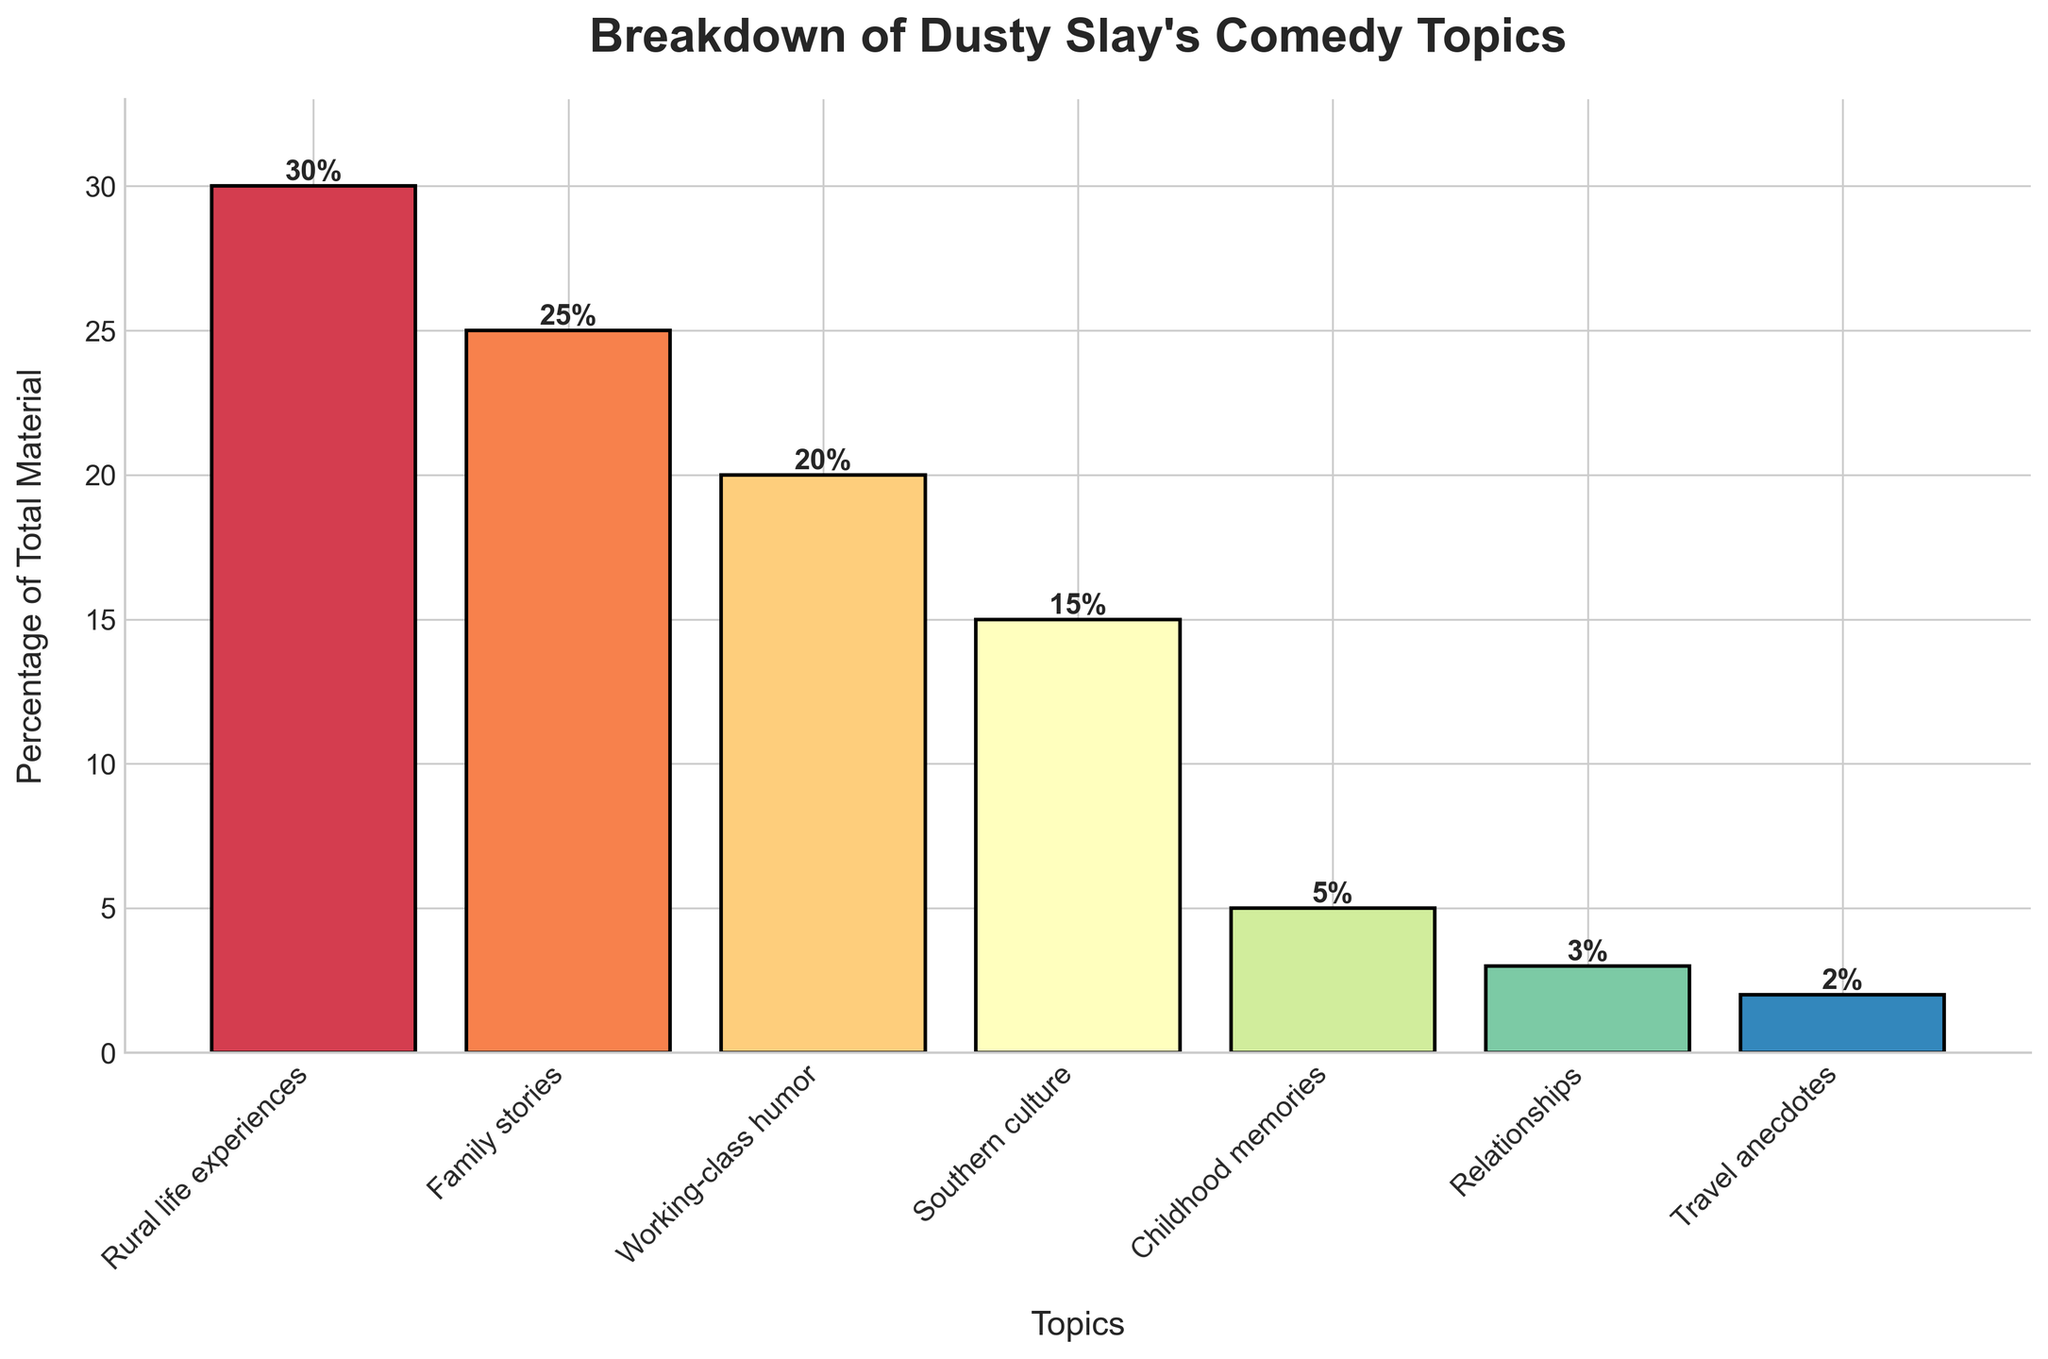Which comedy topic occupies the largest percentage of Dusty Slay's material? The bar labeled as "Rural life experiences" has the tallest height, with a corresponding percentage label of 30%.
Answer: Rural life experiences Which comedy topic has the lowest percentage of total material? The shortest bar on the plot is labeled "Travel anecdotes", showing a percentage of 2%.
Answer: Travel anecdotes What is the sum of the percentages of 'Rural life experiences' and 'Family stories'? The 'Rural life experiences' percentage is 30% and the 'Family stories' percentage is 25%. Adding them together: 30 + 25 = 55%.
Answer: 55% How much greater is the percentage of 'Working-class humor' compared to 'Relationships'? The percentage for 'Working-class humor' is 20% and for 'Relationships' it is 3%. The difference is 20 - 3 = 17%.
Answer: 17% Which topics combined account for half of Dusty Slay's material? Adding together the percentages of 'Rural life experiences' (30%), 'Family stories' (25%), and 'Working-class humor' (20%): 30 + 25 + 20 = 75%. To account for half (50%), we need to either have 'Rural life experiences' alone (30%) and 'Family stories' alone (25%), which together sum to 55%, or just the 'Rural life experiences' (30%) and 'Childhood memories' (5%) which are insufficient. Only 'Rural life experiences' and 'Family stories' combined can exceed 50%.
Answer: Rural life experiences and Family stories Which has a higher percentage: 'Southern culture' or 'Working-class humor'? Comparing the heights and the labels, 'Working-class humor' has a percentage of 20%, which is higher than 'Southern culture' with 15%.
Answer: Working-class humor If Dusty Slay decided to increase 'Childhood memories' by 3% and reduce 'Rural life experiences' by the same amount, would 'Childhood memories' still be less than 'Southern culture'? If 'Childhood memories' percentage is increased by 3%, it changes from 5% to 8%. Meanwhile, 'Rural life experiences' percentage decreases from 30% to 27%. 'Southern culture' remains at 15%, which is still greater than 8%.
Answer: Yes What's the average percentage of material dedicated to 'Family stories', 'Working-class humor', and 'Southern culture'? Adding the percentages for 'Family stories' (25%), 'Working-class humor' (20%), and 'Southern culture' (15%): 25 + 20 + 15 = 60%. Dividing by the number of topics: 60 / 3 = 20%.
Answer: 20% What percentage of the material is not related to 'Rural life experiences', 'Family stories', or 'Working-class humor'? Adding up the specified percentages: 30% (Rural life experiences) + 25% (Family stories) + 20% (Working-class humor) = 75%. The total percentage is 100%, so the remainder: 100 - 75 = 25%.
Answer: 25% 